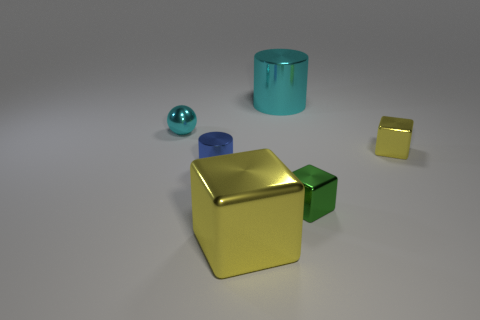There is a big thing that is the same color as the shiny sphere; what is its shape?
Your answer should be very brief. Cylinder. There is a metal cylinder that is the same color as the metal ball; what size is it?
Your answer should be very brief. Large. How many cubes are large matte things or cyan metal things?
Provide a short and direct response. 0. There is a large shiny object in front of the small cyan ball; what is its shape?
Offer a very short reply. Cube. There is a large metal object behind the yellow thing that is left of the big shiny thing behind the tiny cyan metal sphere; what is its color?
Give a very brief answer. Cyan. Is the big yellow block made of the same material as the big cyan object?
Your answer should be very brief. Yes. How many brown objects are either small spheres or tiny metallic cubes?
Provide a short and direct response. 0. There is a ball; how many cyan objects are behind it?
Provide a succinct answer. 1. Are there more tiny blue cylinders than metal cubes?
Offer a terse response. No. What shape is the tiny object that is in front of the cylinder that is in front of the large cyan shiny thing?
Offer a very short reply. Cube. 